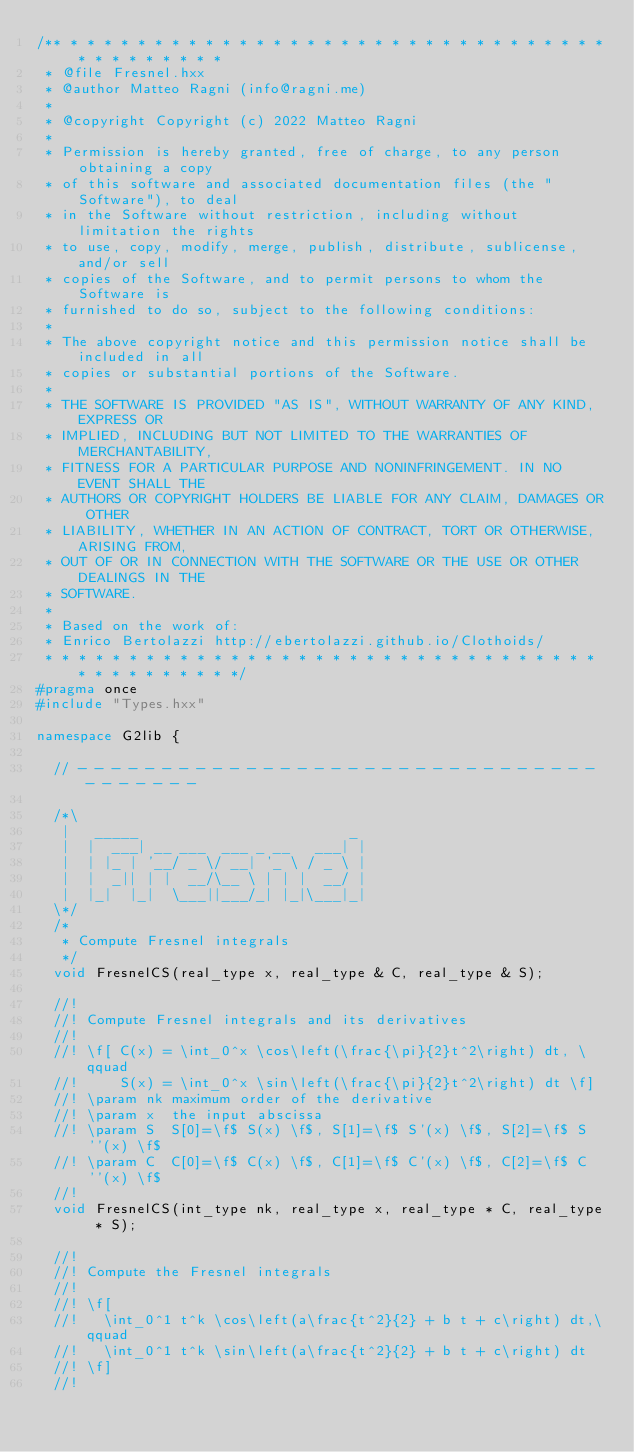<code> <loc_0><loc_0><loc_500><loc_500><_C++_>/** * * * * * * * * * * * * * * * * * * * * * * * * * * * * * * * * * * * * * * * * *
 * @file Fresnel.hxx
 * @author Matteo Ragni (info@ragni.me)
 *
 * @copyright Copyright (c) 2022 Matteo Ragni
 *
 * Permission is hereby granted, free of charge, to any person obtaining a copy
 * of this software and associated documentation files (the "Software"), to deal
 * in the Software without restriction, including without limitation the rights
 * to use, copy, modify, merge, publish, distribute, sublicense, and/or sell
 * copies of the Software, and to permit persons to whom the Software is
 * furnished to do so, subject to the following conditions:
 *
 * The above copyright notice and this permission notice shall be included in all
 * copies or substantial portions of the Software.
 *
 * THE SOFTWARE IS PROVIDED "AS IS", WITHOUT WARRANTY OF ANY KIND, EXPRESS OR
 * IMPLIED, INCLUDING BUT NOT LIMITED TO THE WARRANTIES OF MERCHANTABILITY,
 * FITNESS FOR A PARTICULAR PURPOSE AND NONINFRINGEMENT. IN NO EVENT SHALL THE
 * AUTHORS OR COPYRIGHT HOLDERS BE LIABLE FOR ANY CLAIM, DAMAGES OR OTHER
 * LIABILITY, WHETHER IN AN ACTION OF CONTRACT, TORT OR OTHERWISE, ARISING FROM,
 * OUT OF OR IN CONNECTION WITH THE SOFTWARE OR THE USE OR OTHER DEALINGS IN THE
 * SOFTWARE.
 *
 * Based on the work of:
 * Enrico Bertolazzi http://ebertolazzi.github.io/Clothoids/
 * * * * * * * * * * * * * * * * * * * * * * * * * * * * * * * * * * * * * * * * * * */
#pragma once
#include "Types.hxx"

namespace G2lib {

  // - - - - - - - - - - - - - - - - - - - - - - - - - - - - - - - - - - - - - -

  /*\
   |   _____                         _
   |  |  ___| __ ___  ___ _ __   ___| |
   |  | |_ | '__/ _ \/ __| '_ \ / _ \ |
   |  |  _|| | |  __/\__ \ | | |  __/ |
   |  |_|  |_|  \___||___/_| |_|\___|_|
  \*/
  /*
   * Compute Fresnel integrals
   */
  void FresnelCS(real_type x, real_type & C, real_type & S);

  //!
  //! Compute Fresnel integrals and its derivatives
  //!
  //! \f[ C(x) = \int_0^x \cos\left(\frac{\pi}{2}t^2\right) dt, \qquad
  //!     S(x) = \int_0^x \sin\left(\frac{\pi}{2}t^2\right) dt \f]
  //! \param nk maximum order of the derivative
  //! \param x  the input abscissa
  //! \param S  S[0]=\f$ S(x) \f$, S[1]=\f$ S'(x) \f$, S[2]=\f$ S''(x) \f$
  //! \param C  C[0]=\f$ C(x) \f$, C[1]=\f$ C'(x) \f$, C[2]=\f$ C''(x) \f$
  //!
  void FresnelCS(int_type nk, real_type x, real_type * C, real_type * S);

  //!
  //! Compute the Fresnel integrals
  //!
  //! \f[
  //!   \int_0^1 t^k \cos\left(a\frac{t^2}{2} + b t + c\right) dt,\qquad
  //!   \int_0^1 t^k \sin\left(a\frac{t^2}{2} + b t + c\right) dt
  //! \f]
  //!</code> 